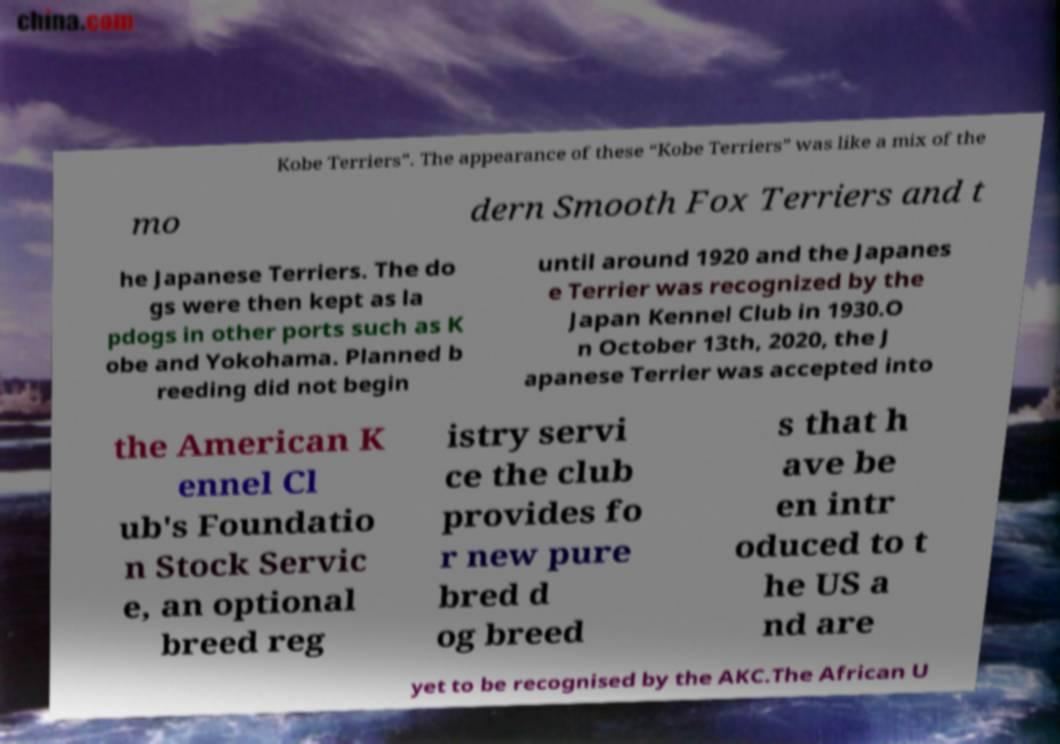I need the written content from this picture converted into text. Can you do that? Kobe Terriers”. The appearance of these “Kobe Terriers” was like a mix of the mo dern Smooth Fox Terriers and t he Japanese Terriers. The do gs were then kept as la pdogs in other ports such as K obe and Yokohama. Planned b reeding did not begin until around 1920 and the Japanes e Terrier was recognized by the Japan Kennel Club in 1930.O n October 13th, 2020, the J apanese Terrier was accepted into the American K ennel Cl ub's Foundatio n Stock Servic e, an optional breed reg istry servi ce the club provides fo r new pure bred d og breed s that h ave be en intr oduced to t he US a nd are yet to be recognised by the AKC.The African U 